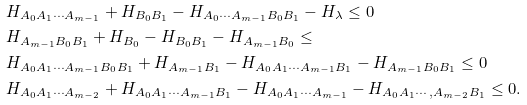<formula> <loc_0><loc_0><loc_500><loc_500>& H _ { A _ { 0 } A _ { 1 } \cdots A _ { m - 1 } } + H _ { B _ { 0 } B _ { 1 } } - H _ { A _ { 0 } \cdots A _ { m - 1 } B _ { 0 } B _ { 1 } } - H _ { \lambda } \leq 0 \\ & H _ { A _ { m - 1 } B _ { 0 } B _ { 1 } } + H _ { B _ { 0 } } - H _ { B _ { 0 } B _ { 1 } } - H _ { A _ { m - 1 } B _ { 0 } } \leq \\ & H _ { A _ { 0 } A _ { 1 } \cdots A _ { m - 1 } B _ { 0 } B _ { 1 } } + H _ { A _ { m - 1 } B _ { 1 } } - H _ { A _ { 0 } A _ { 1 } \cdots A _ { m - 1 } B _ { 1 } } - H _ { A _ { m - 1 } B _ { 0 } B _ { 1 } } \leq 0 \\ & H _ { A _ { 0 } A _ { 1 } \cdots A _ { m - 2 } } + H _ { A _ { 0 } A _ { 1 } \cdots A _ { m - 1 } B _ { 1 } } - H _ { A _ { 0 } A _ { 1 } \cdots A _ { m - 1 } } - H _ { A _ { 0 } A _ { 1 } \cdots , A _ { m - 2 } B _ { 1 } } \leq 0 .</formula> 